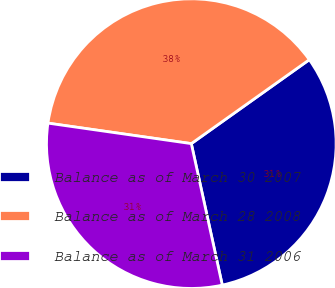Convert chart to OTSL. <chart><loc_0><loc_0><loc_500><loc_500><pie_chart><fcel>Balance as of March 30 2007<fcel>Balance as of March 28 2008<fcel>Balance as of March 31 2006<nl><fcel>31.41%<fcel>37.9%<fcel>30.69%<nl></chart> 